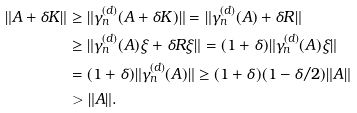Convert formula to latex. <formula><loc_0><loc_0><loc_500><loc_500>\| A + \delta K \| & \geq \| \gamma _ { n } ^ { ( d ) } ( A + \delta K ) \| = \| \gamma _ { n } ^ { ( d ) } ( A ) + \delta R \| \\ & \geq \| \gamma _ { n } ^ { ( d ) } ( A ) \xi + \delta R \xi \| = ( 1 + \delta ) \| \gamma _ { n } ^ { ( d ) } ( A ) \xi \| \\ & = ( 1 + \delta ) \| \gamma _ { n } ^ { ( d ) } ( A ) \| \geq ( 1 + \delta ) ( 1 - \delta / 2 ) \| A \| \\ & > \| A \| .</formula> 